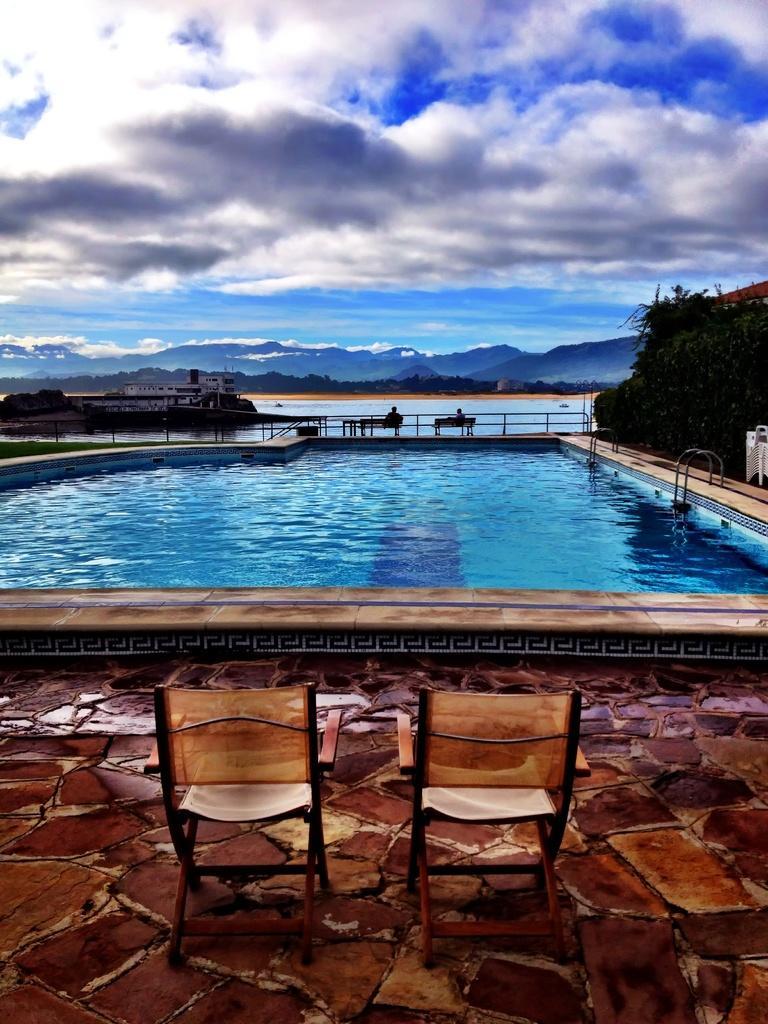Could you give a brief overview of what you see in this image? In this image in the front there are empty chairs in the center there is a water and in the background there are trees and there are persons sitting on bench and there are mountains and the sky is cloudy. 